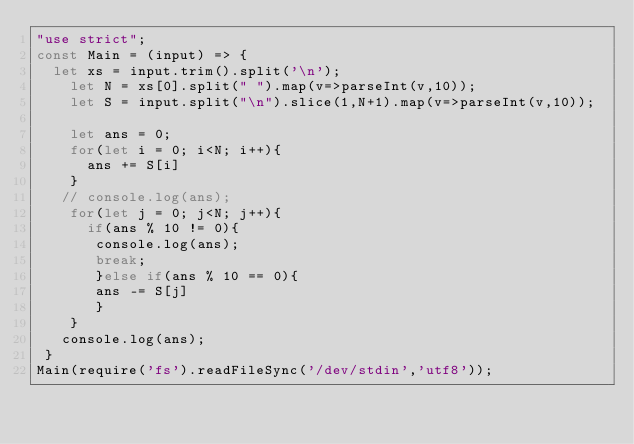<code> <loc_0><loc_0><loc_500><loc_500><_JavaScript_>"use strict";
const Main = (input) => {
	let xs = input.trim().split('\n');
    let N = xs[0].split(" ").map(v=>parseInt(v,10));
    let S = input.split("\n").slice(1,N+1).map(v=>parseInt(v,10)); 

    let ans = 0;
    for(let i = 0; i<N; i++){
      ans += S[i]
    }
   // console.log(ans);
    for(let j = 0; j<N; j++){ 
      if(ans % 10 != 0){
       console.log(ans);
       break;
       }else if(ans % 10 == 0){
       ans -= S[j]
       }
    }   
   console.log(ans);
 }
Main(require('fs').readFileSync('/dev/stdin','utf8'));</code> 